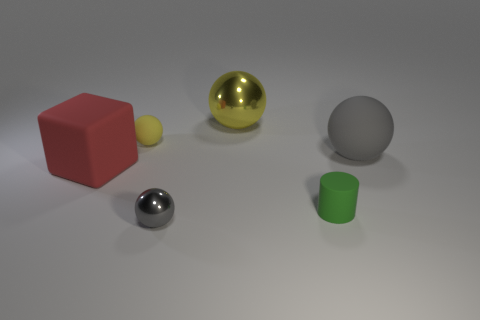Is the number of small blue metal spheres greater than the number of small yellow objects?
Offer a terse response. No. What number of things are either small spheres or metallic objects that are behind the tiny green thing?
Offer a very short reply. 3. Does the red matte block have the same size as the yellow shiny sphere?
Ensure brevity in your answer.  Yes. Are there any green matte objects behind the tiny green thing?
Your response must be concise. No. What is the size of the object that is in front of the big red cube and right of the large yellow metallic thing?
Provide a short and direct response. Small. How many things are brown matte blocks or tiny objects?
Make the answer very short. 3. Do the red rubber object and the rubber cylinder on the right side of the yellow rubber sphere have the same size?
Keep it short and to the point. No. There is a shiny ball that is in front of the tiny object that is on the left side of the gray metal sphere to the right of the large red object; what size is it?
Your answer should be compact. Small. Are any brown metal objects visible?
Provide a succinct answer. No. There is a big object that is the same color as the small matte ball; what is its material?
Offer a terse response. Metal. 